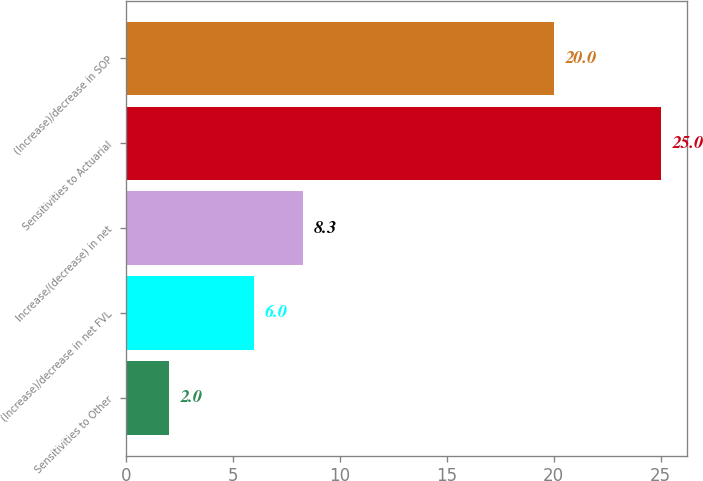Convert chart. <chart><loc_0><loc_0><loc_500><loc_500><bar_chart><fcel>Sensitivities to Other<fcel>(Increase)/decrease in net FVL<fcel>Increase/(decrease) in net<fcel>Sensitivities to Actuarial<fcel>(Increase)/decrease in SOP<nl><fcel>2<fcel>6<fcel>8.3<fcel>25<fcel>20<nl></chart> 